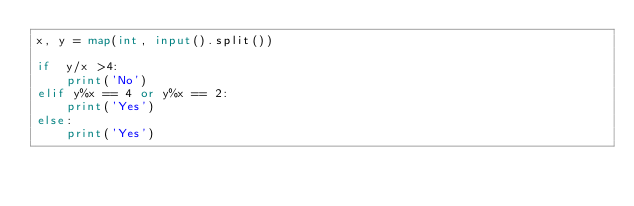<code> <loc_0><loc_0><loc_500><loc_500><_Python_>x, y = map(int, input().split())

if  y/x >4:
    print('No')
elif y%x == 4 or y%x == 2:
    print('Yes')
else:
    print('Yes')</code> 